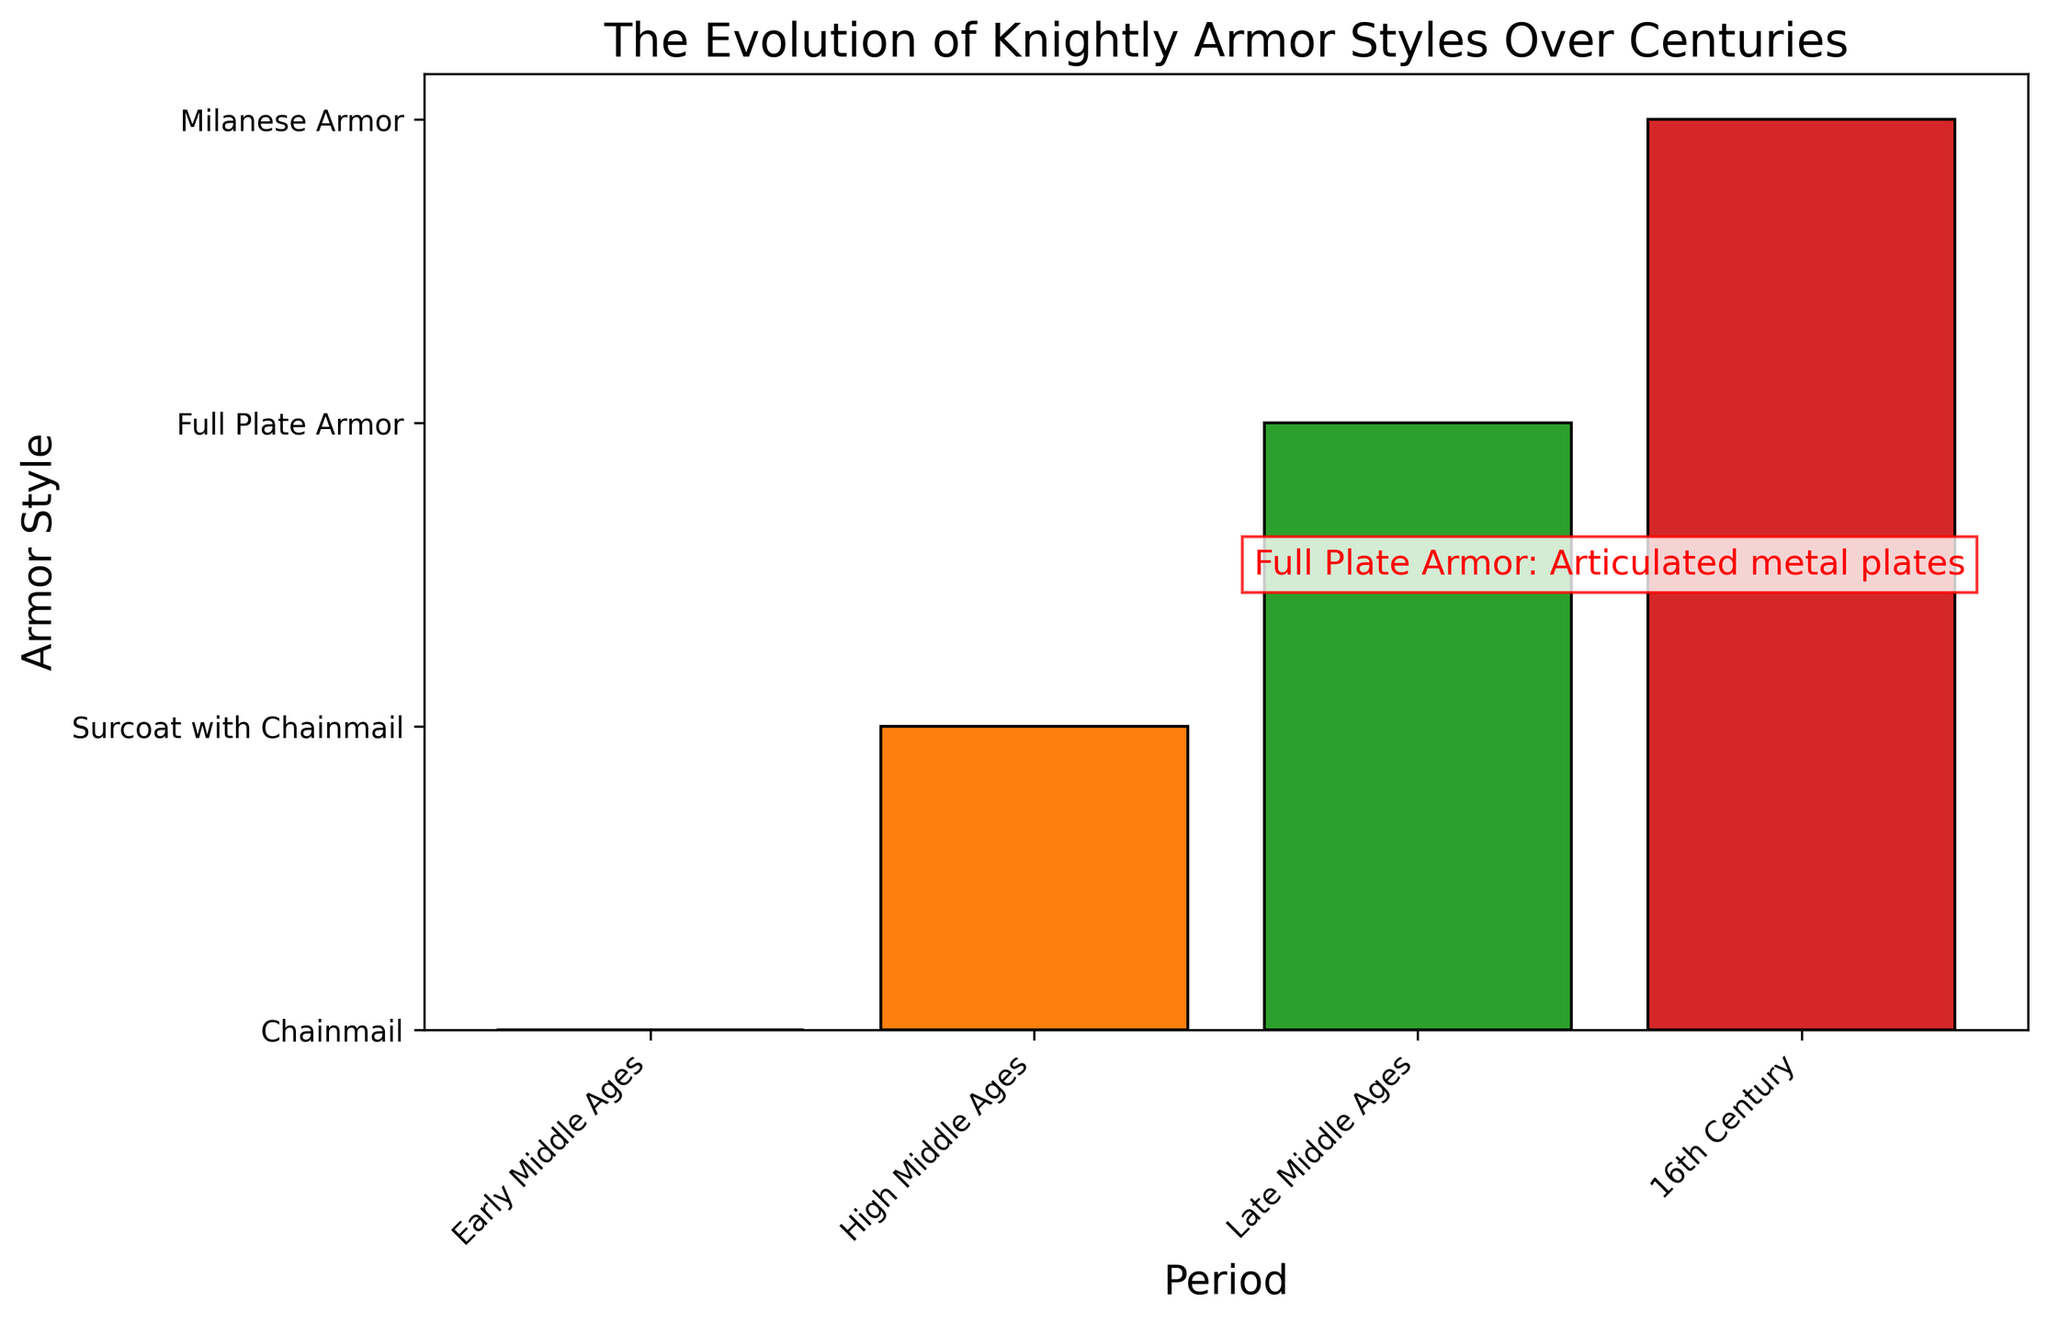What is the key feature of the armor style during the Late Middle Ages? The figure shows "Full Plate Armor" associated with the Late Middle Ages. The text annotation highlights its key feature as "Articulated metal plates."
Answer: Articulated metal plates Which period features Milanese Armor? By observing the X-axis labels and matching them with the corresponding bars, Milanese Armor appears in the 16th Century.
Answer: 16th Century What are the armor styles listed in the figure? By reading the Y-axis labels, we can identify the armor styles as Chainmail, Surcoat with Chainmail, Full Plate Armor, and Milanese Armor.
Answer: Chainmail, Surcoat with Chainmail, Full Plate Armor, Milanese Armor How is the Early Middle Ages armor style different from that of the High Middle Ages? Comparing the key features of both periods, the Early Middle Ages features Chainmail while the High Middle Ages features a Surcoat with Chainmail. The distinguishing element is the brightly-colored tunic over the chainmail in the High Middle Ages.
Answer: Surcoat with Chainmail has a brightly-colored tunic over chainmail; Chainmail is just flexible metal meshwork Which armor style is considered the most iconic according to the figure? The text annotation on the figure highlights "Full Plate Armor" with a description, indicating it as the most iconic.
Answer: Full Plate Armor What is the visual indication for the text annotation on the figure? The text annotation saying "Full Plate Armor: Articulated metal plates" is marked in red color and positioned centrally above the bars.
Answer: Red color text annotation above the bars Between the Early and Late Middle Ages, which armor style had more advanced design features? The key feature for the Early Middle Ages is "Flexible metal meshwork" (Chainmail), while for the Late Middle Ages, it is "Articulated metal plates" (Full Plate Armor). Articulated metal plates represent a more advanced design due to increased protection and maneuverability.
Answer: Full Plate Armor What are the colors used for the bars representing different periods? The figure uses different colors for each period's bars: blue for the Early Middle Ages, orange for the High Middle Ages, green for the Late Middle Ages, and red for the 16th Century.
Answer: Blue, orange, green, red How does the High Middle Ages armor style visually differ from the 16th Century armor style? The High Middle Ages features "Surcoat with Chainmail" which includes a brightly-colored tunic over chainmail, while the 16th Century features "Milanese Armor" with a rounded and smooth design. The High Middle Ages armor emphasizes color and layered elements, whereas the 16th Century armor focuses on rounded forms.
Answer: Brightly-colored tunic over chainmail vs. rounded and smooth design 